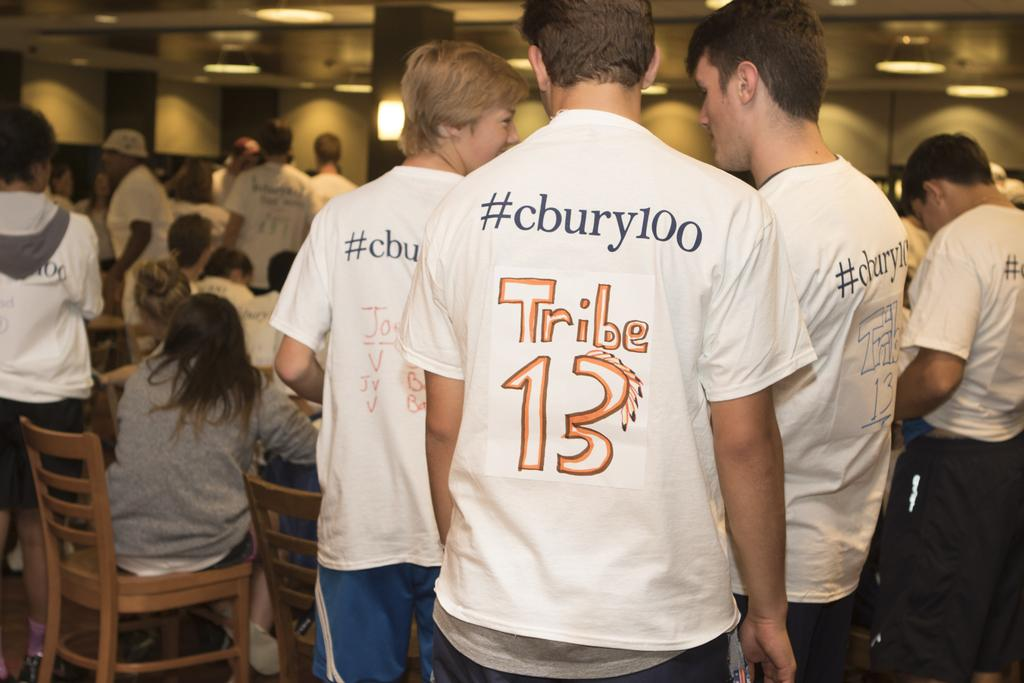What are the majority of the persons in the image wearing? Most of the persons in the image are wearing white t-shirts. What are the persons in the image doing? The persons are standing. What furniture can be seen in the image? There are chairs in the image. What are some persons doing with the chairs? Some persons are sitting on the chairs. What is visible at the top of the image? There are lights visible at the top of the image. What month is it in the image? The month cannot be determined from the image, as there is no information about the time of year. Are there any balloons present in the image? There is no mention of balloons in the provided facts, so it cannot be determined if they are present in the image. 